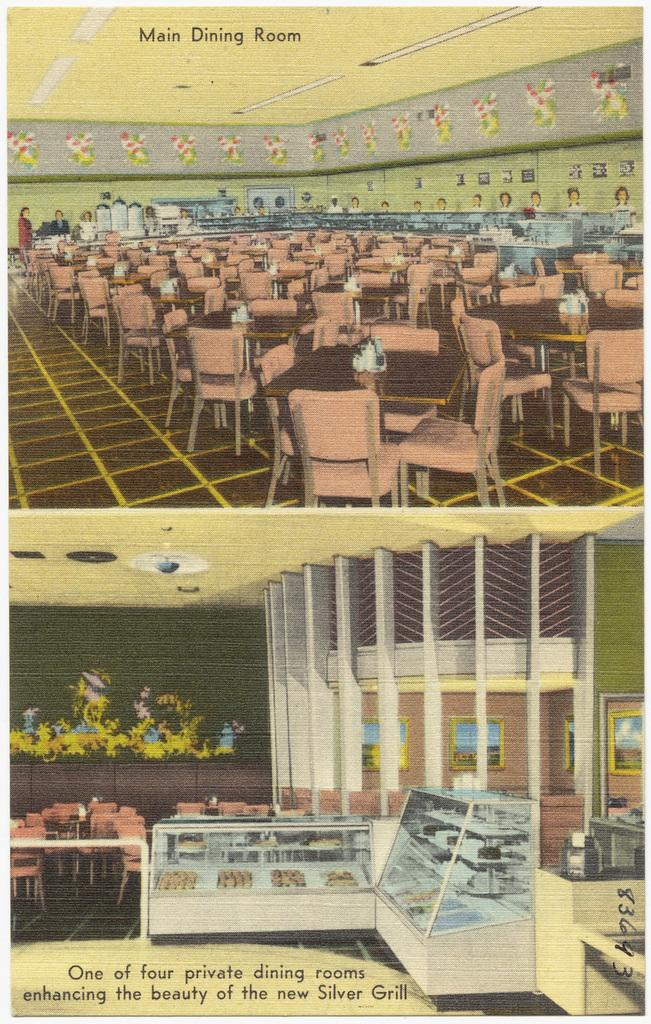What type of image is being described? The image is a collage. Can you describe the style of the image? The image is graphical in nature. What type of wine is being served in the image? There is no wine present in the image, as it is a collage of graphical elements. 